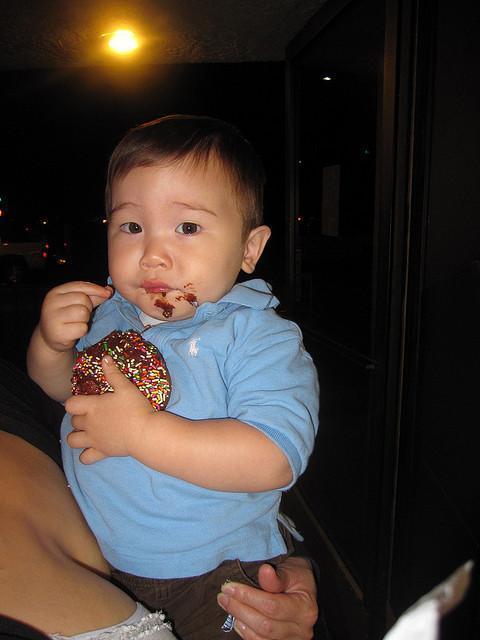How many people are visible?
Give a very brief answer. 2. 